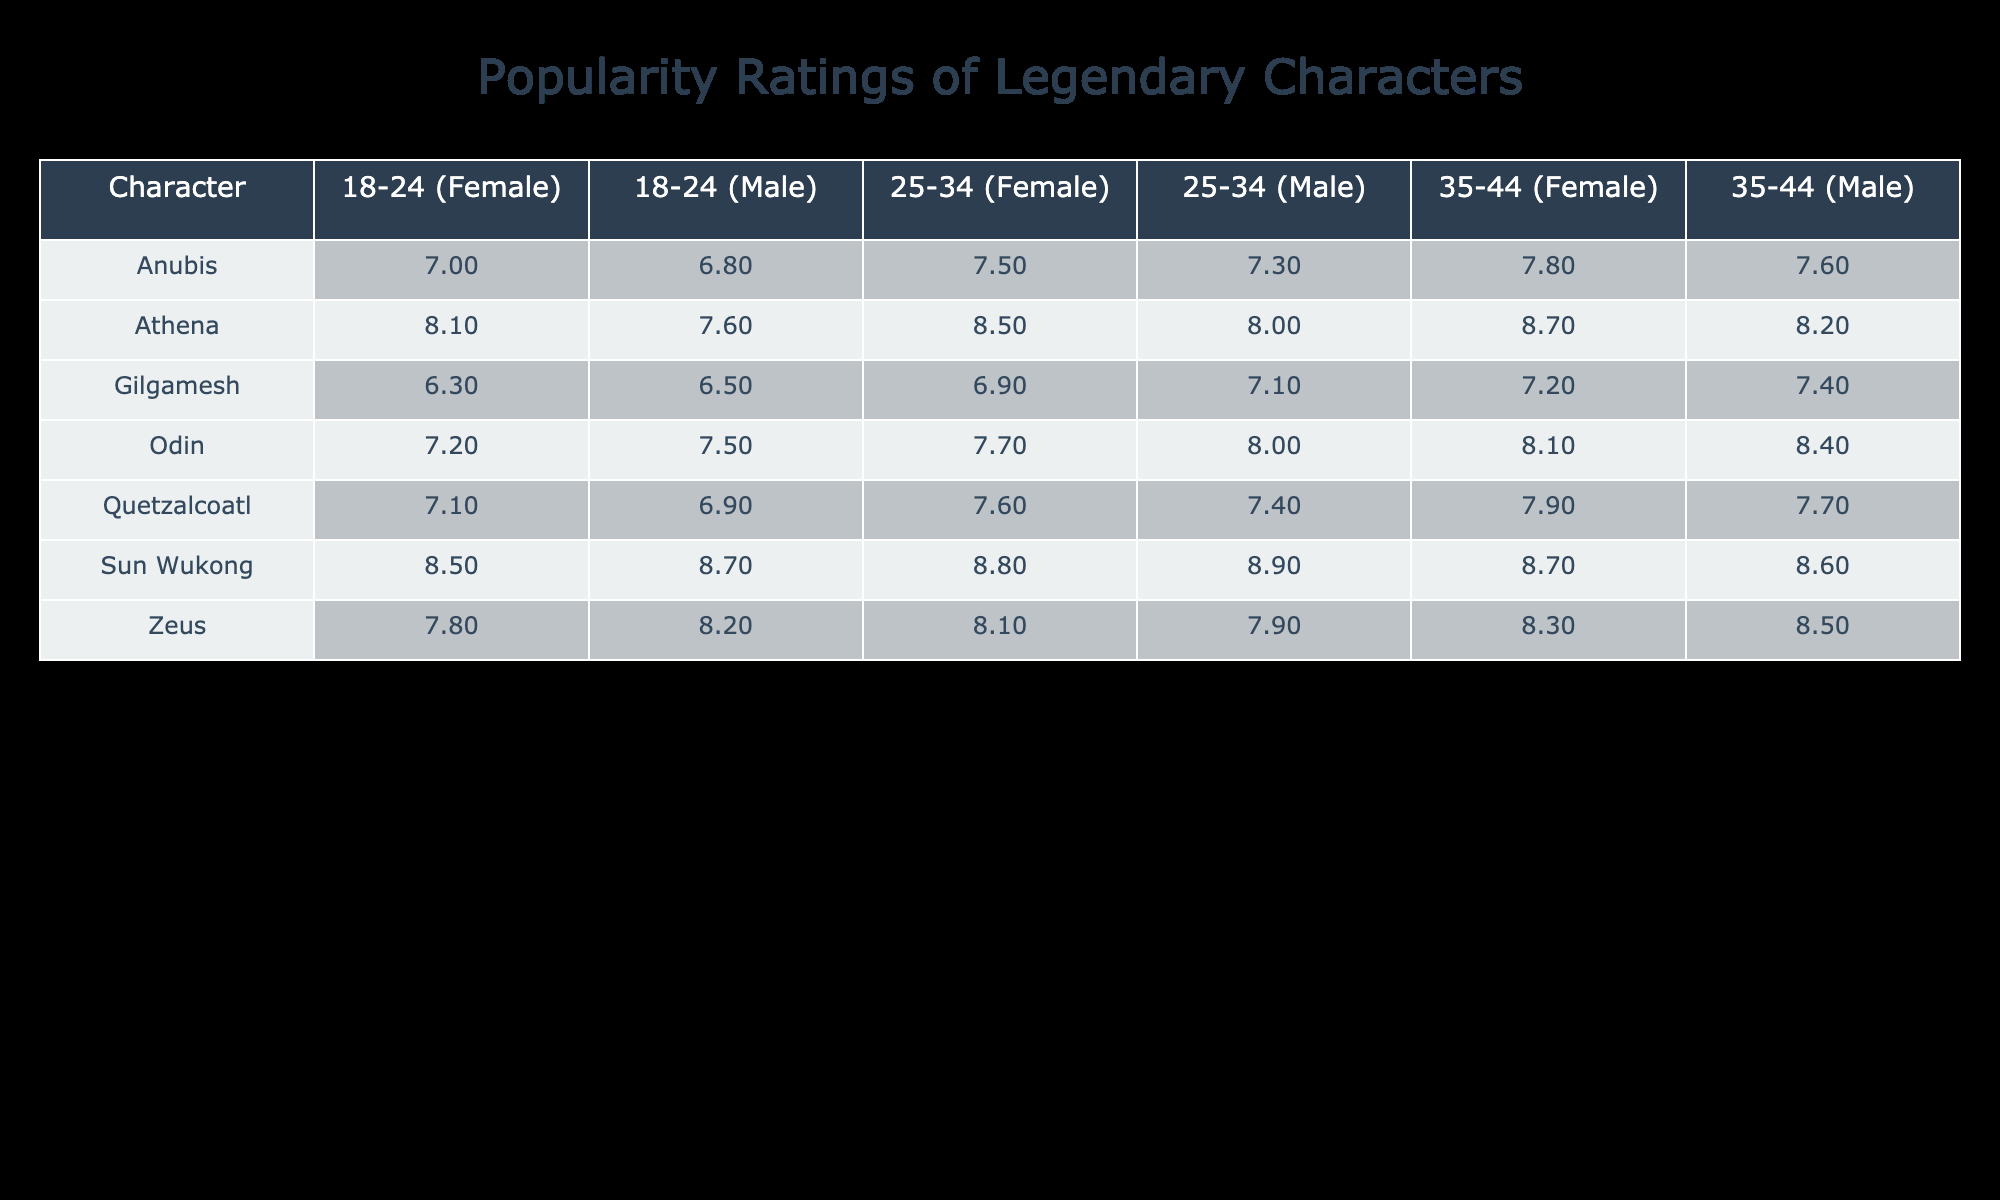What is the popularity rating of Sun Wukong for females aged 25-34? The popularity rating for Sun Wukong in that category is listed directly in the table. By checking the corresponding cell for females aged 25-34 under Sun Wukong, it shows a rating of 8.8.
Answer: 8.8 Which character has the highest popularity rating among males in the 18-24 age group? To determine this, you look at the popularity ratings for all characters in the 18-24 male category: Zeus (8.2), Odin (7.5), Anubis (6.8), Gilgamesh (6.5), Sun Wukong (8.7), Athena (7.6), and Quetzalcoatl (6.9). The highest among these is Sun Wukong at 8.7.
Answer: Sun Wukong Is the average popularity rating for Athena among females aged 35-44 higher than that for Zeus? For Athena, the rating for females aged 35-44 is 8.7, and for Zeus, it is 8.3. To compare, 8.7 (Athena) is greater than 8.3 (Zeus), hence Athena's rating is higher.
Answer: Yes What is the total popularity rating for males aged 35-44 across all characters? To find this, sum the ratings for males aged 35-44: Zeus (8.5), Odin (8.4), Anubis (7.6), Gilgamesh (7.4), Sun Wukong (8.6), Athena (8.2), and Quetzalcoatl (7.7). This gives a total of 8.5 + 8.4 + 7.6 + 7.4 + 8.6 + 8.2 + 7.7 = 57.4.
Answer: 57.4 Does Anubis have a higher popularity rating among females aged 25-34 compared to males in the same age group? For females aged 25-34, Anubis has a rating of 7.5. For males in the same age group, Anubis has a rating of 7.3. Since 7.5 (females) is greater than 7.3 (males), Anubis does indeed have a higher rating among females.
Answer: Yes 